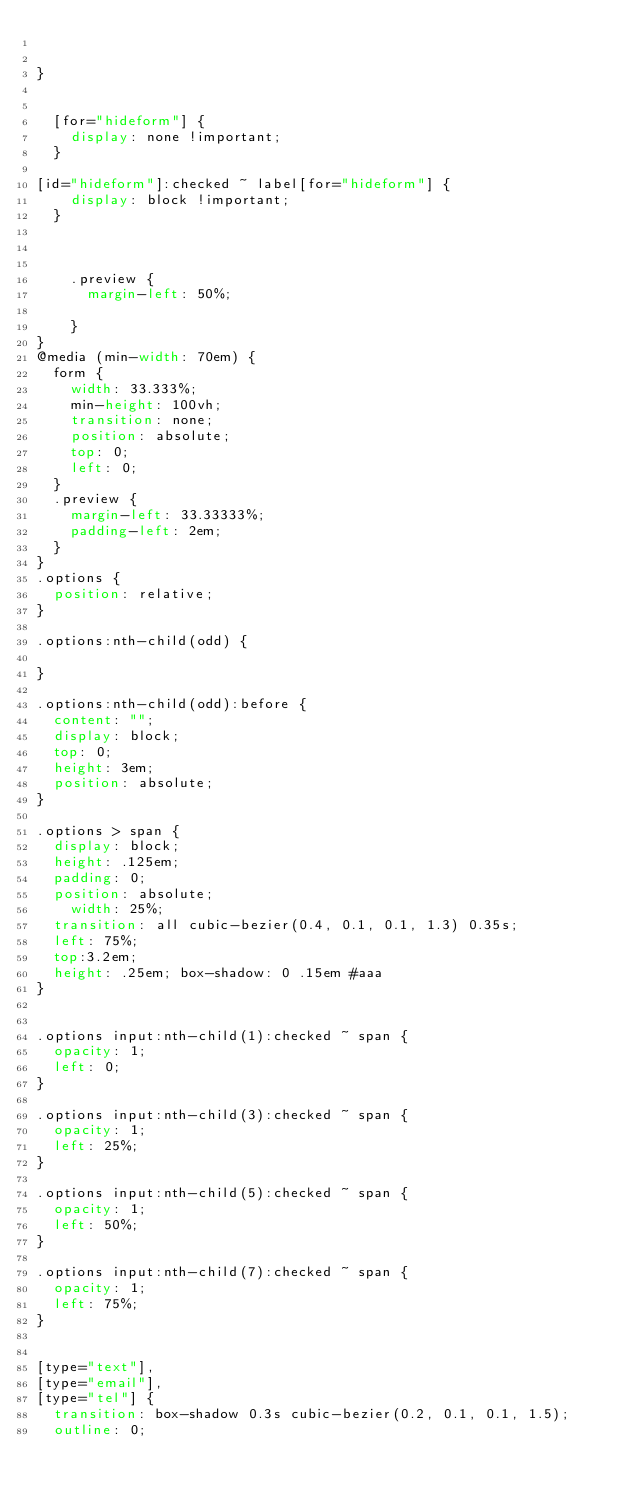<code> <loc_0><loc_0><loc_500><loc_500><_CSS_>

}


  [for="hideform"] {
    display: none !important;
  }

[id="hideform"]:checked ~ label[for="hideform"] {
    display: block !important;
  }



    .preview {
      margin-left: 50%;

    }
}
@media (min-width: 70em) {
  form {
    width: 33.333%;
    min-height: 100vh;
    transition: none;
    position: absolute;
    top: 0;
    left: 0;
  }
  .preview {
    margin-left: 33.33333%;
    padding-left: 2em;
  }
}
.options {
  position: relative;
}

.options:nth-child(odd) {

}

.options:nth-child(odd):before {
  content: "";
  display: block;
  top: 0;
  height: 3em;
  position: absolute;
}

.options > span {
  display: block;
  height: .125em;
  padding: 0;
  position: absolute;
    width: 25%;
  transition: all cubic-bezier(0.4, 0.1, 0.1, 1.3) 0.35s;
  left: 75%;
  top:3.2em;
  height: .25em; box-shadow: 0 .15em #aaa
}


.options input:nth-child(1):checked ~ span {
  opacity: 1;
  left: 0;
}

.options input:nth-child(3):checked ~ span {
  opacity: 1;
  left: 25%;
}

.options input:nth-child(5):checked ~ span {
  opacity: 1;
  left: 50%;
}

.options input:nth-child(7):checked ~ span {
  opacity: 1;
  left: 75%;
}


[type="text"],
[type="email"],
[type="tel"] {
  transition: box-shadow 0.3s cubic-bezier(0.2, 0.1, 0.1, 1.5);
  outline: 0;</code> 